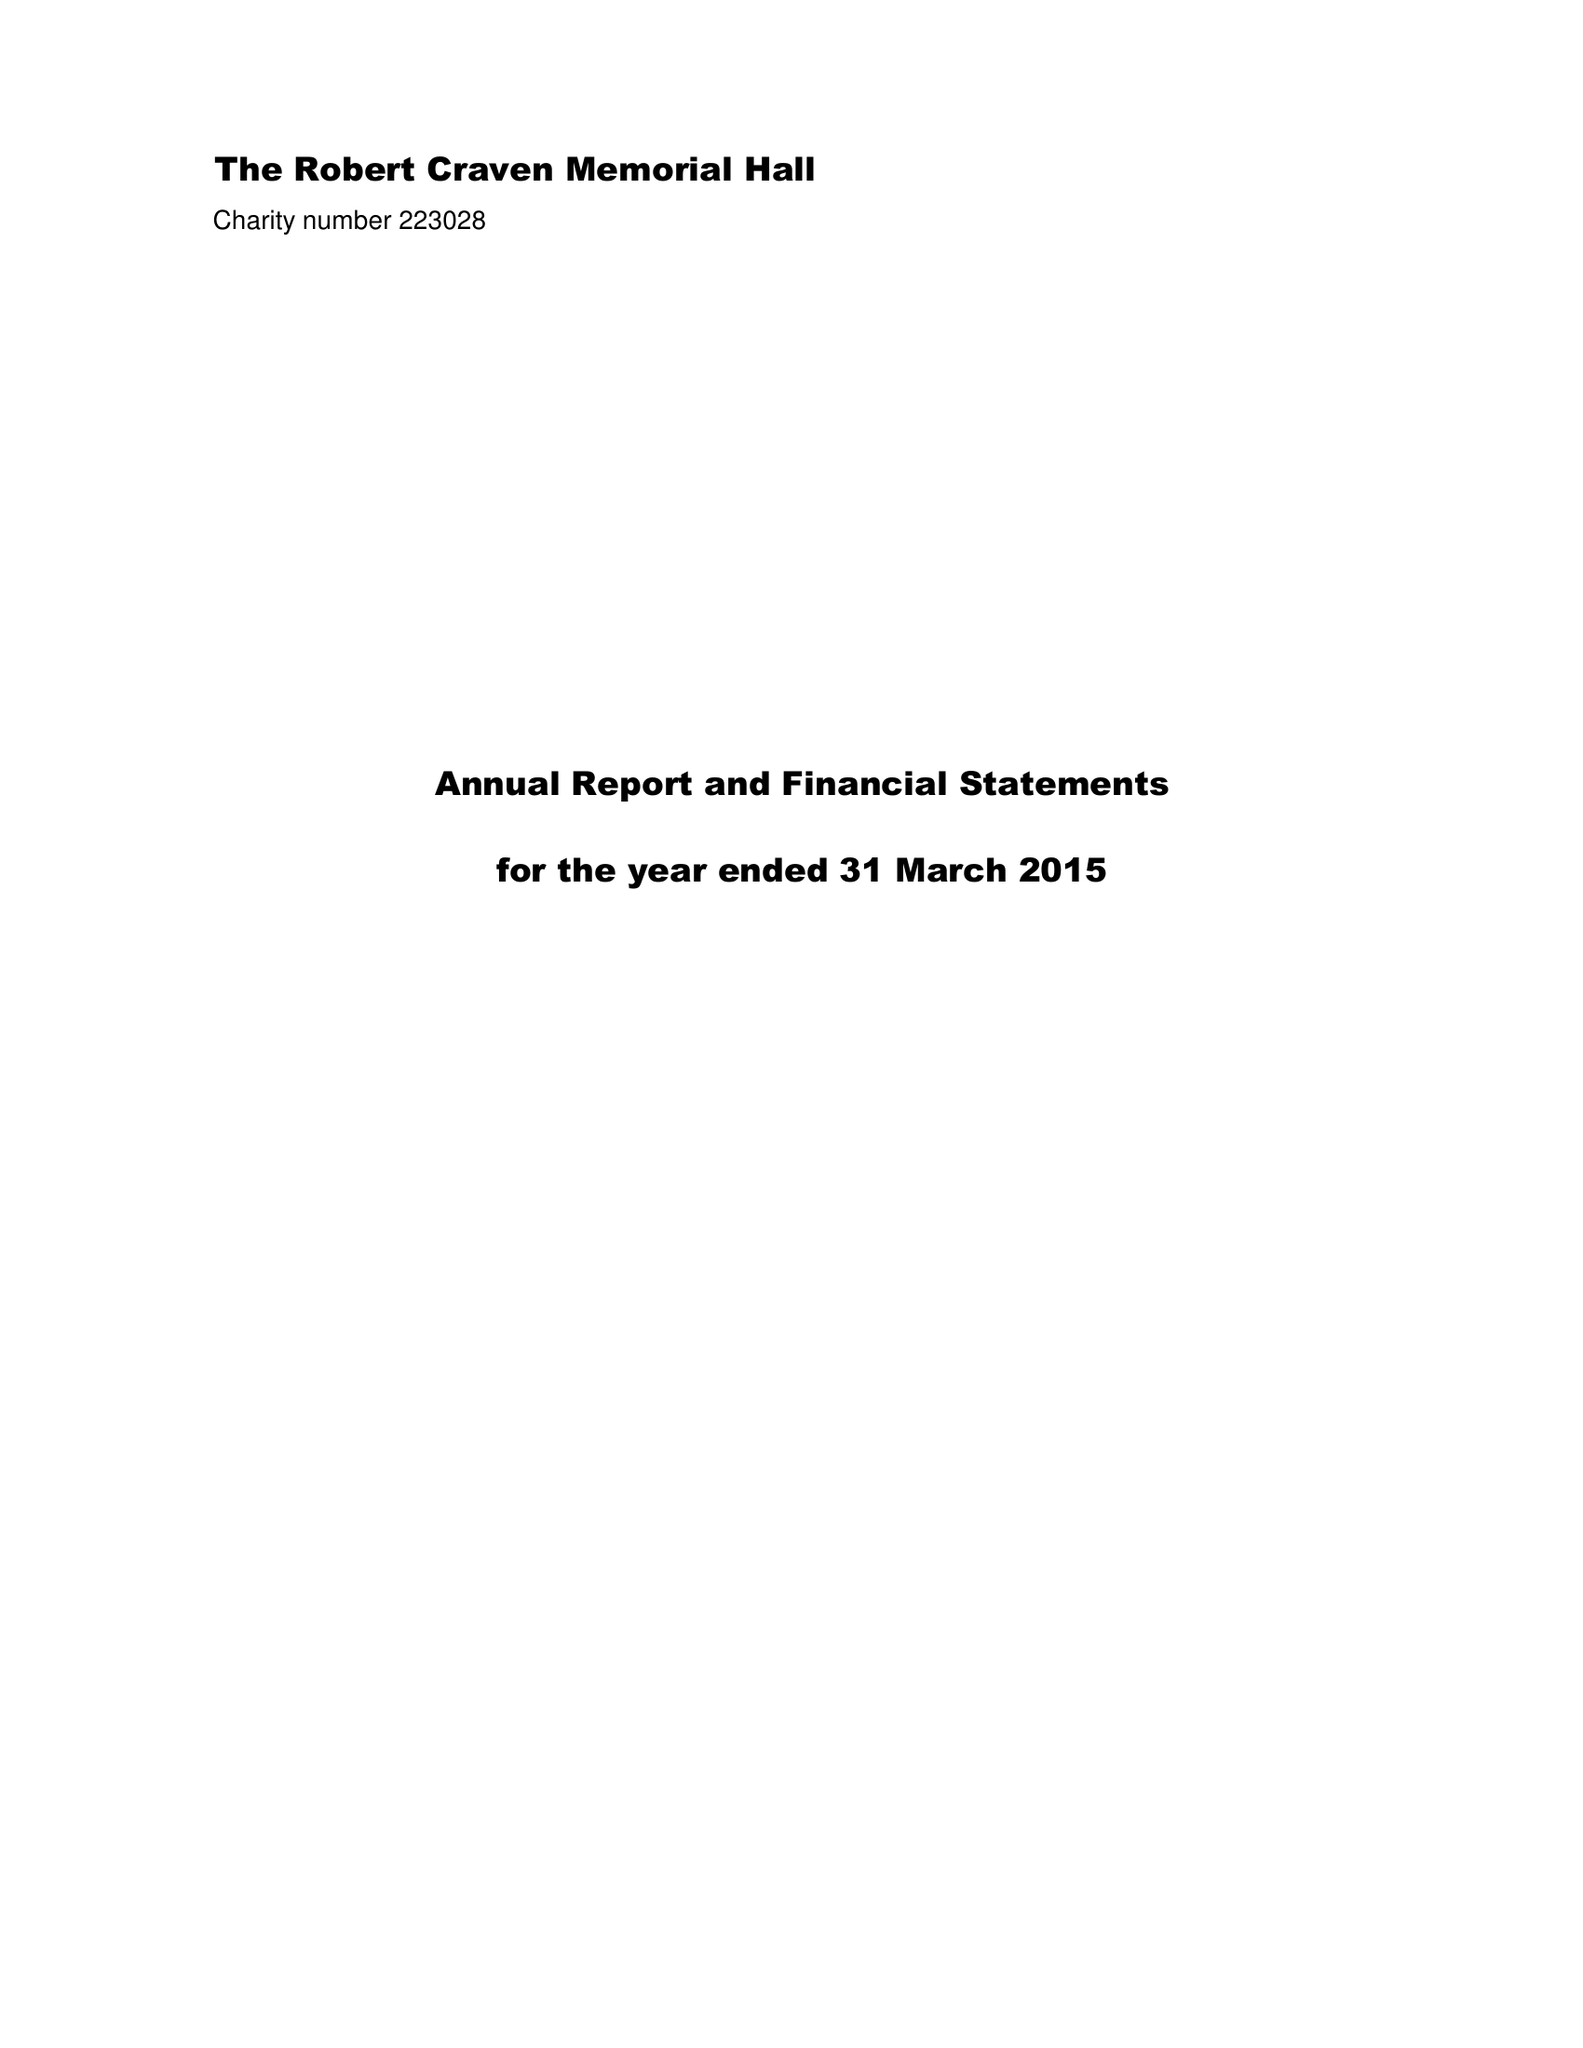What is the value for the spending_annually_in_british_pounds?
Answer the question using a single word or phrase. 33988.00 